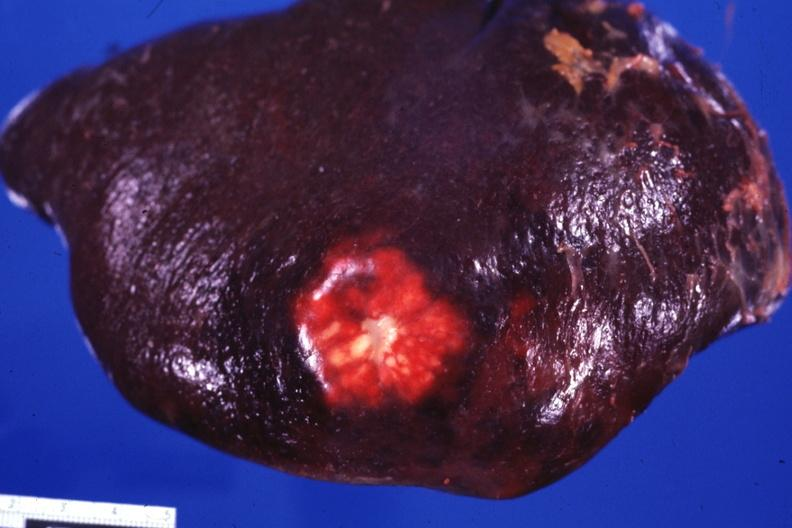where is this part in?
Answer the question using a single word or phrase. Spleen 